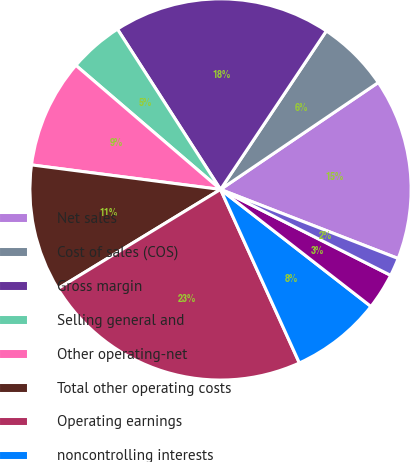Convert chart. <chart><loc_0><loc_0><loc_500><loc_500><pie_chart><fcel>Net sales<fcel>Cost of sales (COS)<fcel>Gross margin<fcel>Selling general and<fcel>Other operating-net<fcel>Total other operating costs<fcel>Operating earnings<fcel>noncontrolling interests<fcel>Natural gas costs in COS (1)<fcel>Cost of natural gas in COS<nl><fcel>15.38%<fcel>6.15%<fcel>18.46%<fcel>4.62%<fcel>9.23%<fcel>10.77%<fcel>23.07%<fcel>7.69%<fcel>3.08%<fcel>1.54%<nl></chart> 